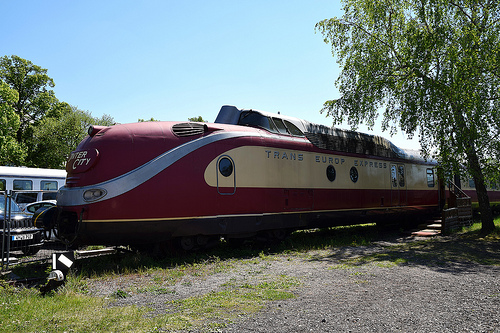<image>
Can you confirm if the train is behind the tree? Yes. From this viewpoint, the train is positioned behind the tree, with the tree partially or fully occluding the train. 